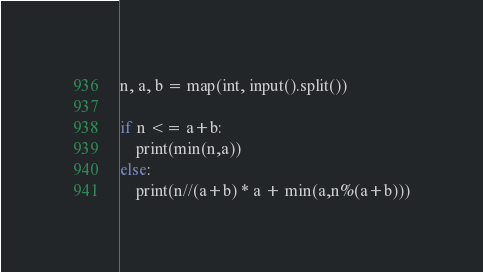<code> <loc_0><loc_0><loc_500><loc_500><_Python_>n, a, b = map(int, input().split())

if n <= a+b:
    print(min(n,a))
else:
    print(n//(a+b) * a + min(a,n%(a+b)))</code> 